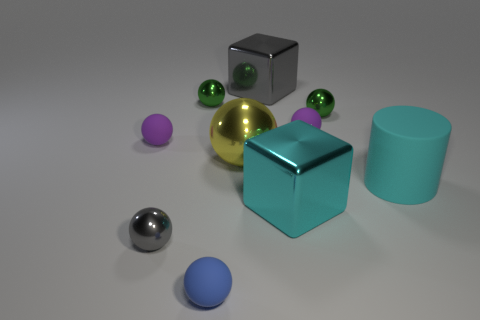Subtract all big metallic balls. How many balls are left? 6 Subtract all cyan cylinders. How many green spheres are left? 2 Subtract all gray blocks. How many blocks are left? 1 Subtract all balls. How many objects are left? 3 Subtract 1 cyan blocks. How many objects are left? 9 Subtract 3 spheres. How many spheres are left? 4 Subtract all green cubes. Subtract all brown cylinders. How many cubes are left? 2 Subtract all gray metal things. Subtract all yellow metal spheres. How many objects are left? 7 Add 7 tiny blue matte balls. How many tiny blue matte balls are left? 8 Add 8 blue metal things. How many blue metal things exist? 8 